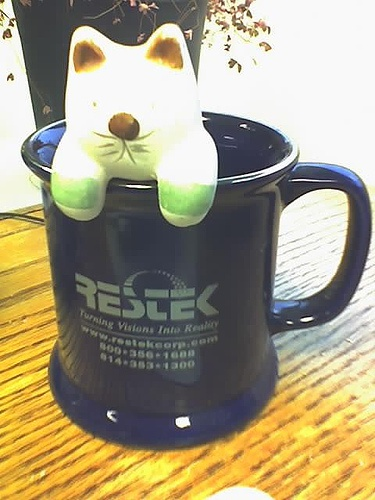Describe the objects in this image and their specific colors. I can see dining table in brown, gray, ivory, black, and gold tones, cup in brown, gray, black, and white tones, and potted plant in brown, gray, ivory, and black tones in this image. 